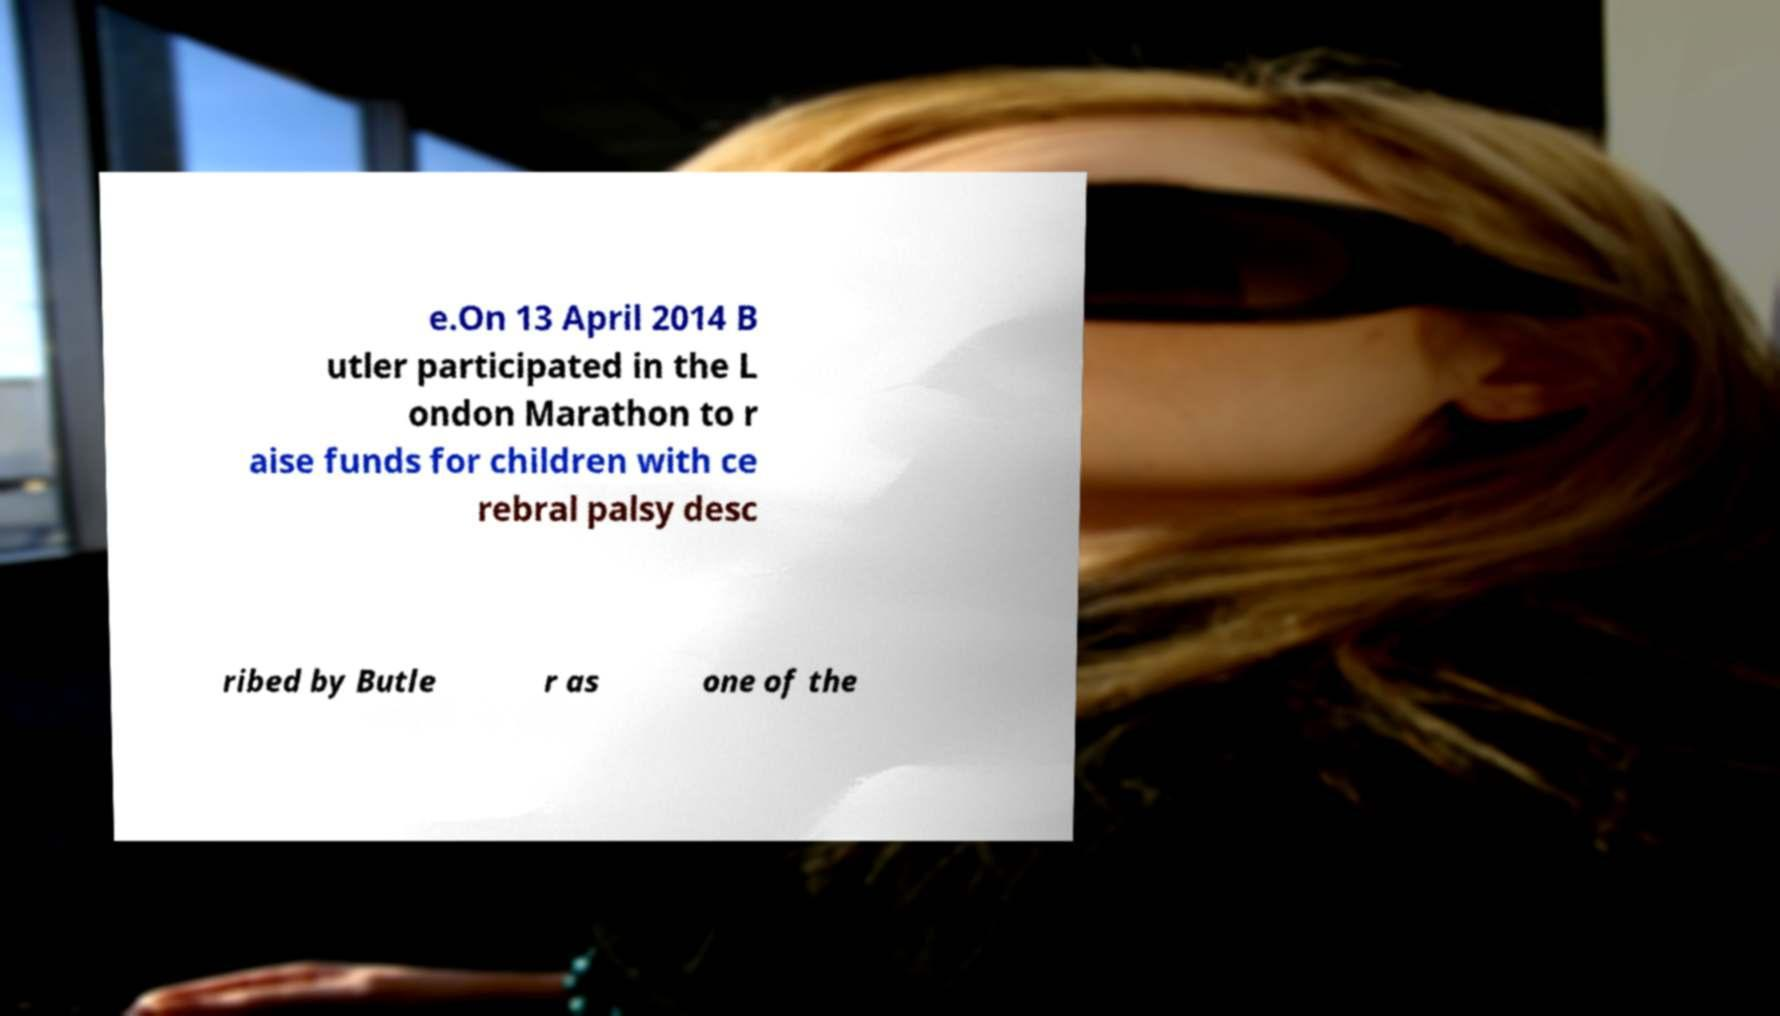Can you read and provide the text displayed in the image?This photo seems to have some interesting text. Can you extract and type it out for me? e.On 13 April 2014 B utler participated in the L ondon Marathon to r aise funds for children with ce rebral palsy desc ribed by Butle r as one of the 